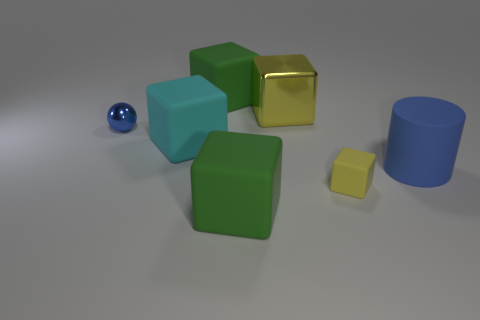Subtract all cyan cubes. How many cubes are left? 4 Subtract all large cyan matte cubes. How many cubes are left? 4 Subtract 2 cubes. How many cubes are left? 3 Subtract all purple blocks. Subtract all green balls. How many blocks are left? 5 Add 1 large cyan rubber cubes. How many objects exist? 8 Subtract all blocks. How many objects are left? 2 Add 6 small green shiny cylinders. How many small green shiny cylinders exist? 6 Subtract 0 green cylinders. How many objects are left? 7 Subtract all tiny purple metallic cylinders. Subtract all blue metallic spheres. How many objects are left? 6 Add 6 tiny yellow blocks. How many tiny yellow blocks are left? 7 